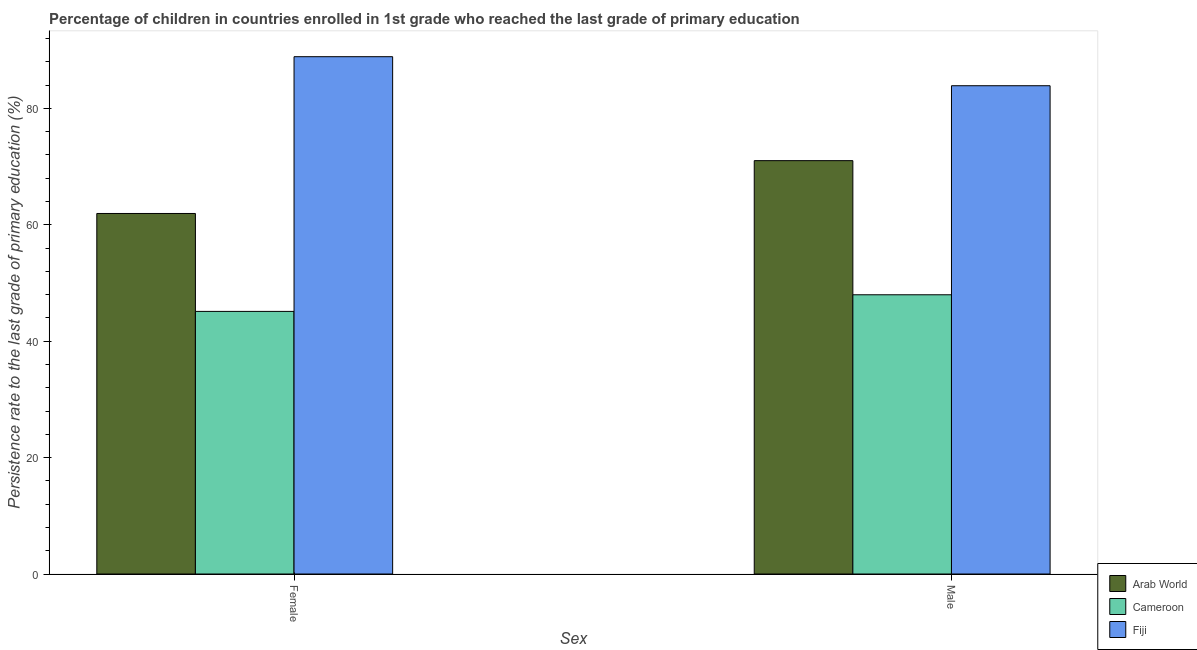What is the persistence rate of female students in Arab World?
Ensure brevity in your answer.  61.94. Across all countries, what is the maximum persistence rate of female students?
Give a very brief answer. 88.88. Across all countries, what is the minimum persistence rate of female students?
Make the answer very short. 45.12. In which country was the persistence rate of male students maximum?
Your response must be concise. Fiji. In which country was the persistence rate of male students minimum?
Provide a succinct answer. Cameroon. What is the total persistence rate of female students in the graph?
Your answer should be very brief. 195.93. What is the difference between the persistence rate of male students in Cameroon and that in Arab World?
Provide a short and direct response. -23.05. What is the difference between the persistence rate of male students in Fiji and the persistence rate of female students in Arab World?
Your response must be concise. 21.95. What is the average persistence rate of male students per country?
Your answer should be very brief. 67.62. What is the difference between the persistence rate of male students and persistence rate of female students in Cameroon?
Your response must be concise. 2.86. What is the ratio of the persistence rate of female students in Cameroon to that in Fiji?
Provide a short and direct response. 0.51. Is the persistence rate of female students in Fiji less than that in Arab World?
Offer a very short reply. No. In how many countries, is the persistence rate of female students greater than the average persistence rate of female students taken over all countries?
Give a very brief answer. 1. What does the 2nd bar from the left in Female represents?
Your answer should be compact. Cameroon. What does the 1st bar from the right in Female represents?
Your answer should be compact. Fiji. Are all the bars in the graph horizontal?
Offer a very short reply. No. How many countries are there in the graph?
Provide a succinct answer. 3. Are the values on the major ticks of Y-axis written in scientific E-notation?
Provide a succinct answer. No. Does the graph contain any zero values?
Provide a succinct answer. No. How many legend labels are there?
Offer a terse response. 3. How are the legend labels stacked?
Offer a terse response. Vertical. What is the title of the graph?
Keep it short and to the point. Percentage of children in countries enrolled in 1st grade who reached the last grade of primary education. Does "Lebanon" appear as one of the legend labels in the graph?
Your answer should be compact. No. What is the label or title of the X-axis?
Make the answer very short. Sex. What is the label or title of the Y-axis?
Keep it short and to the point. Persistence rate to the last grade of primary education (%). What is the Persistence rate to the last grade of primary education (%) in Arab World in Female?
Provide a short and direct response. 61.94. What is the Persistence rate to the last grade of primary education (%) in Cameroon in Female?
Your answer should be compact. 45.12. What is the Persistence rate to the last grade of primary education (%) in Fiji in Female?
Offer a terse response. 88.88. What is the Persistence rate to the last grade of primary education (%) in Arab World in Male?
Offer a terse response. 71.02. What is the Persistence rate to the last grade of primary education (%) in Cameroon in Male?
Make the answer very short. 47.97. What is the Persistence rate to the last grade of primary education (%) of Fiji in Male?
Offer a very short reply. 83.89. Across all Sex, what is the maximum Persistence rate to the last grade of primary education (%) in Arab World?
Provide a succinct answer. 71.02. Across all Sex, what is the maximum Persistence rate to the last grade of primary education (%) of Cameroon?
Offer a terse response. 47.97. Across all Sex, what is the maximum Persistence rate to the last grade of primary education (%) of Fiji?
Your response must be concise. 88.88. Across all Sex, what is the minimum Persistence rate to the last grade of primary education (%) of Arab World?
Your answer should be very brief. 61.94. Across all Sex, what is the minimum Persistence rate to the last grade of primary education (%) in Cameroon?
Offer a very short reply. 45.12. Across all Sex, what is the minimum Persistence rate to the last grade of primary education (%) in Fiji?
Provide a short and direct response. 83.89. What is the total Persistence rate to the last grade of primary education (%) in Arab World in the graph?
Offer a very short reply. 132.96. What is the total Persistence rate to the last grade of primary education (%) of Cameroon in the graph?
Provide a short and direct response. 93.09. What is the total Persistence rate to the last grade of primary education (%) of Fiji in the graph?
Give a very brief answer. 172.76. What is the difference between the Persistence rate to the last grade of primary education (%) in Arab World in Female and that in Male?
Your answer should be very brief. -9.08. What is the difference between the Persistence rate to the last grade of primary education (%) in Cameroon in Female and that in Male?
Provide a succinct answer. -2.86. What is the difference between the Persistence rate to the last grade of primary education (%) in Fiji in Female and that in Male?
Your response must be concise. 4.99. What is the difference between the Persistence rate to the last grade of primary education (%) in Arab World in Female and the Persistence rate to the last grade of primary education (%) in Cameroon in Male?
Your answer should be very brief. 13.97. What is the difference between the Persistence rate to the last grade of primary education (%) in Arab World in Female and the Persistence rate to the last grade of primary education (%) in Fiji in Male?
Offer a very short reply. -21.95. What is the difference between the Persistence rate to the last grade of primary education (%) of Cameroon in Female and the Persistence rate to the last grade of primary education (%) of Fiji in Male?
Give a very brief answer. -38.77. What is the average Persistence rate to the last grade of primary education (%) in Arab World per Sex?
Provide a succinct answer. 66.48. What is the average Persistence rate to the last grade of primary education (%) of Cameroon per Sex?
Your answer should be compact. 46.54. What is the average Persistence rate to the last grade of primary education (%) of Fiji per Sex?
Keep it short and to the point. 86.38. What is the difference between the Persistence rate to the last grade of primary education (%) of Arab World and Persistence rate to the last grade of primary education (%) of Cameroon in Female?
Make the answer very short. 16.82. What is the difference between the Persistence rate to the last grade of primary education (%) in Arab World and Persistence rate to the last grade of primary education (%) in Fiji in Female?
Your response must be concise. -26.94. What is the difference between the Persistence rate to the last grade of primary education (%) in Cameroon and Persistence rate to the last grade of primary education (%) in Fiji in Female?
Your answer should be compact. -43.76. What is the difference between the Persistence rate to the last grade of primary education (%) of Arab World and Persistence rate to the last grade of primary education (%) of Cameroon in Male?
Provide a short and direct response. 23.05. What is the difference between the Persistence rate to the last grade of primary education (%) in Arab World and Persistence rate to the last grade of primary education (%) in Fiji in Male?
Provide a short and direct response. -12.87. What is the difference between the Persistence rate to the last grade of primary education (%) in Cameroon and Persistence rate to the last grade of primary education (%) in Fiji in Male?
Give a very brief answer. -35.92. What is the ratio of the Persistence rate to the last grade of primary education (%) of Arab World in Female to that in Male?
Your answer should be compact. 0.87. What is the ratio of the Persistence rate to the last grade of primary education (%) in Cameroon in Female to that in Male?
Your answer should be very brief. 0.94. What is the ratio of the Persistence rate to the last grade of primary education (%) of Fiji in Female to that in Male?
Your response must be concise. 1.06. What is the difference between the highest and the second highest Persistence rate to the last grade of primary education (%) of Arab World?
Give a very brief answer. 9.08. What is the difference between the highest and the second highest Persistence rate to the last grade of primary education (%) in Cameroon?
Offer a terse response. 2.86. What is the difference between the highest and the second highest Persistence rate to the last grade of primary education (%) in Fiji?
Your answer should be compact. 4.99. What is the difference between the highest and the lowest Persistence rate to the last grade of primary education (%) in Arab World?
Give a very brief answer. 9.08. What is the difference between the highest and the lowest Persistence rate to the last grade of primary education (%) in Cameroon?
Ensure brevity in your answer.  2.86. What is the difference between the highest and the lowest Persistence rate to the last grade of primary education (%) of Fiji?
Make the answer very short. 4.99. 